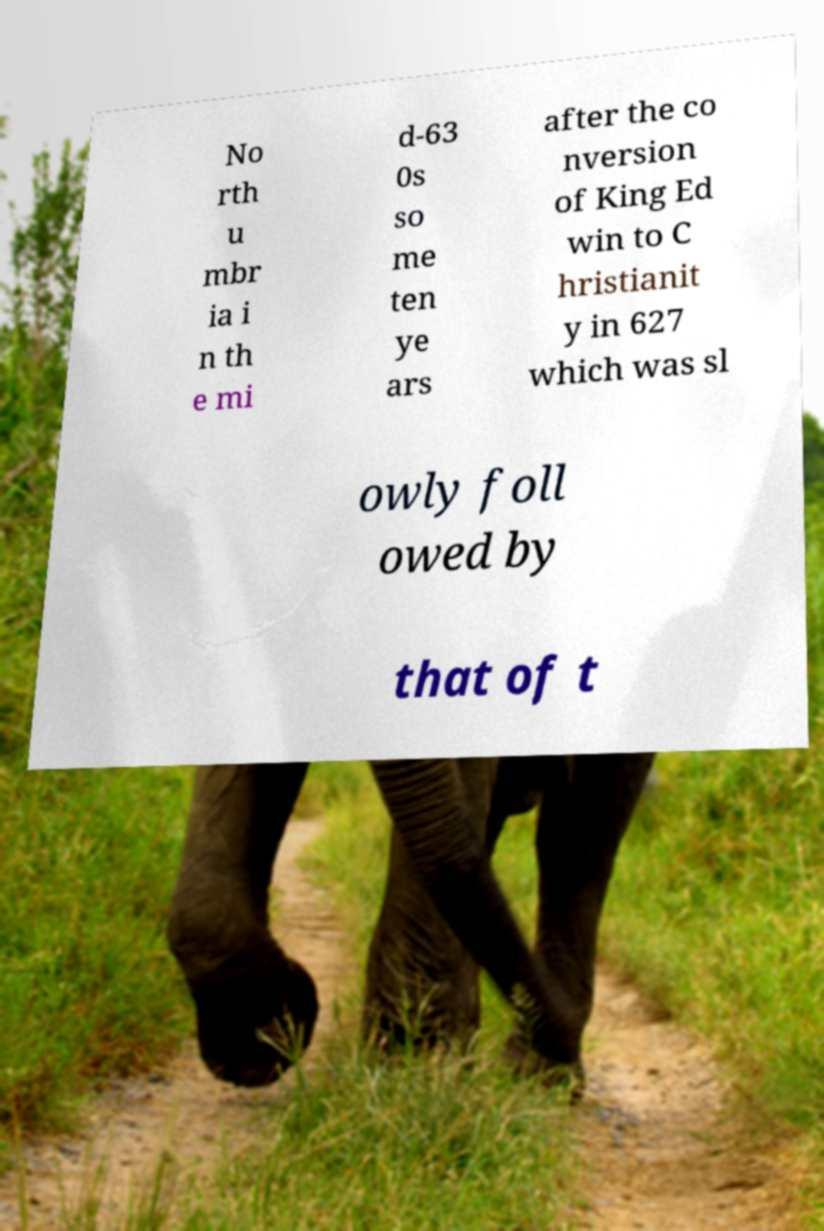Can you accurately transcribe the text from the provided image for me? No rth u mbr ia i n th e mi d-63 0s so me ten ye ars after the co nversion of King Ed win to C hristianit y in 627 which was sl owly foll owed by that of t 